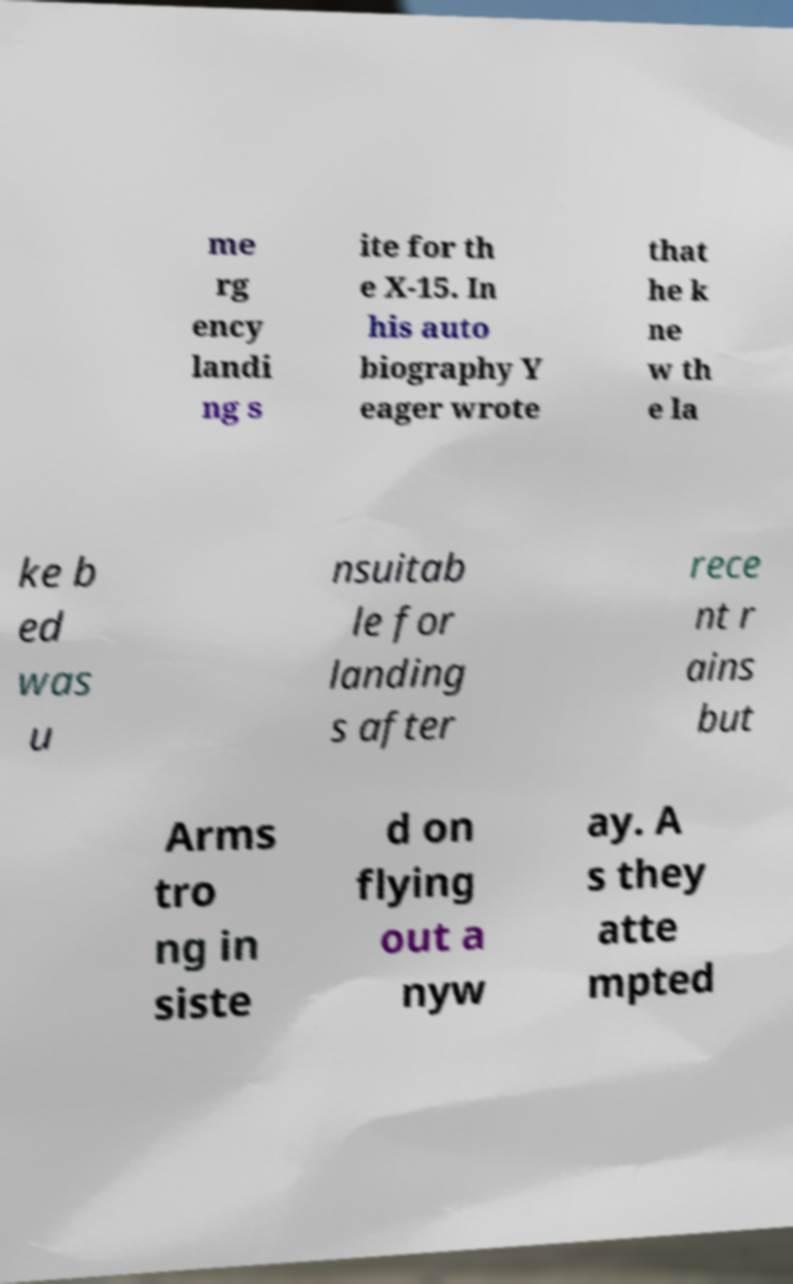For documentation purposes, I need the text within this image transcribed. Could you provide that? me rg ency landi ng s ite for th e X-15. In his auto biography Y eager wrote that he k ne w th e la ke b ed was u nsuitab le for landing s after rece nt r ains but Arms tro ng in siste d on flying out a nyw ay. A s they atte mpted 